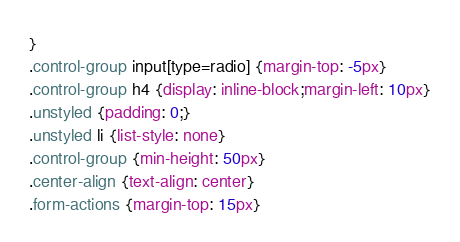Convert code to text. <code><loc_0><loc_0><loc_500><loc_500><_CSS_>}
.control-group input[type=radio] {margin-top: -5px}
.control-group h4 {display: inline-block;margin-left: 10px}
.unstyled {padding: 0;}
.unstyled li {list-style: none}
.control-group {min-height: 50px}
.center-align {text-align: center}
.form-actions {margin-top: 15px}</code> 